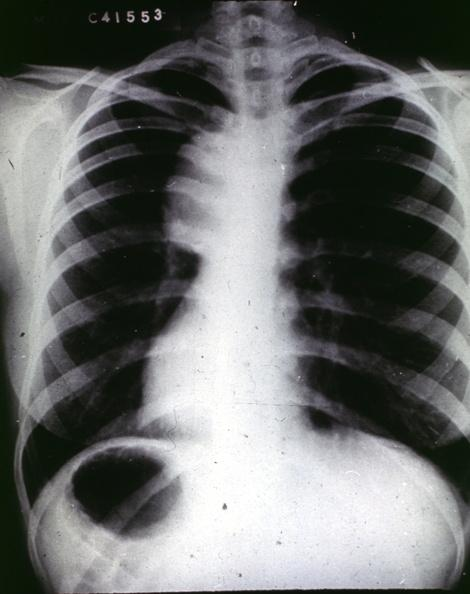what is present?
Answer the question using a single word or phrase. Aorta 